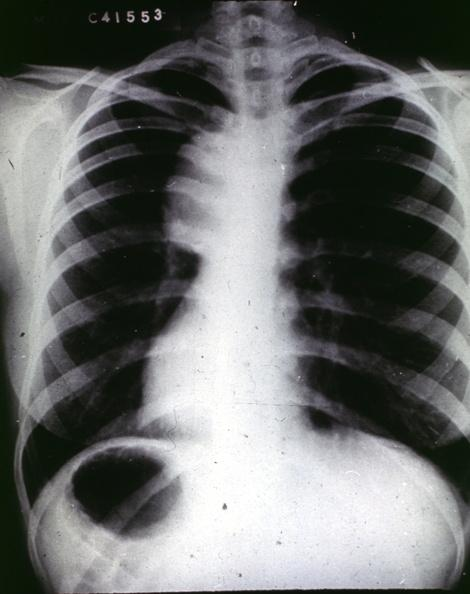what is present?
Answer the question using a single word or phrase. Aorta 